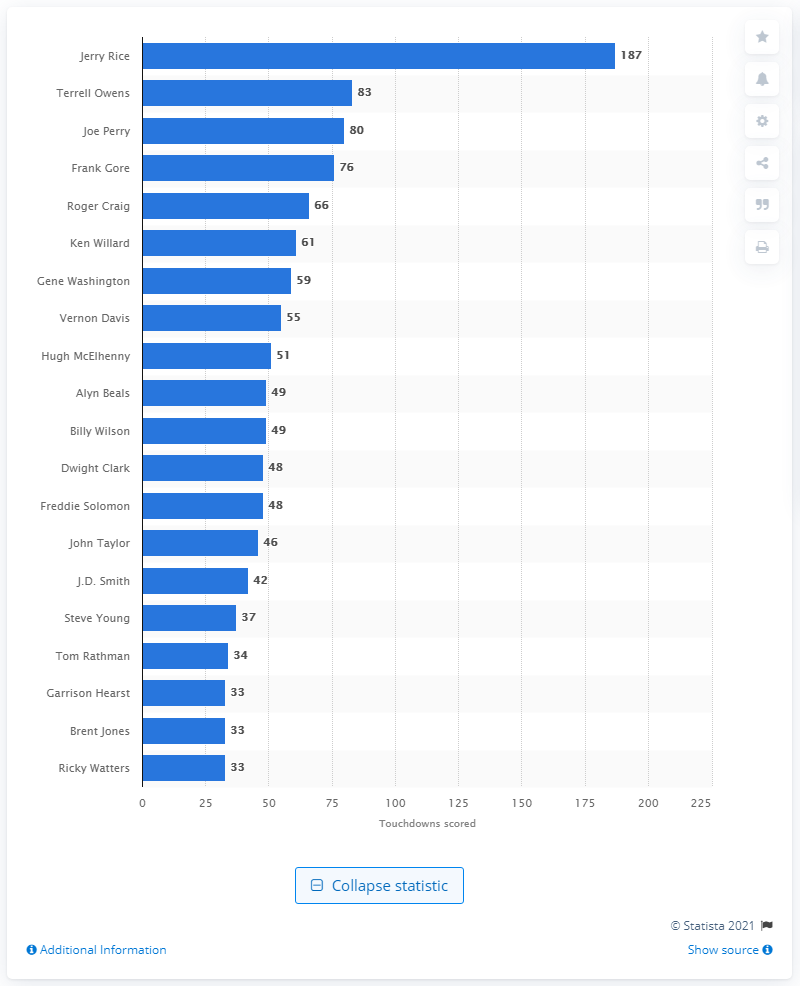Point out several critical features in this image. Jerry Rice is the career touchdown leader of the San Francisco 49ers. 